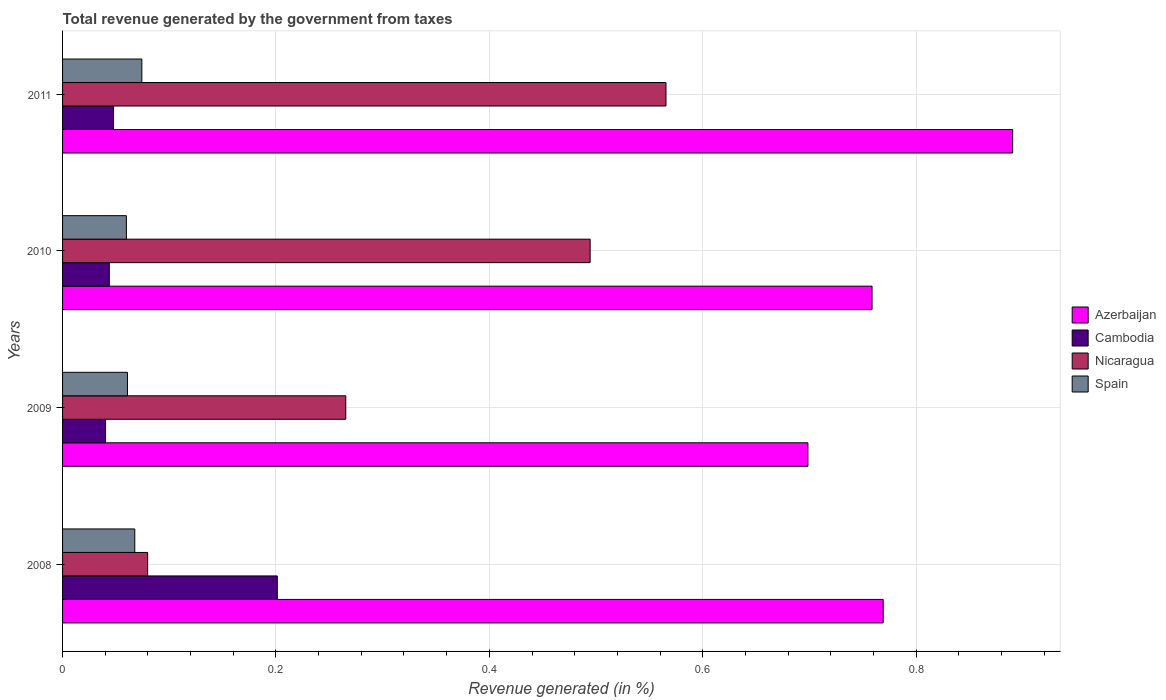Are the number of bars per tick equal to the number of legend labels?
Keep it short and to the point. Yes. Are the number of bars on each tick of the Y-axis equal?
Your answer should be compact. Yes. How many bars are there on the 4th tick from the top?
Ensure brevity in your answer.  4. How many bars are there on the 3rd tick from the bottom?
Offer a very short reply. 4. In how many cases, is the number of bars for a given year not equal to the number of legend labels?
Your answer should be very brief. 0. What is the total revenue generated in Nicaragua in 2009?
Your answer should be compact. 0.27. Across all years, what is the maximum total revenue generated in Spain?
Make the answer very short. 0.07. Across all years, what is the minimum total revenue generated in Cambodia?
Give a very brief answer. 0.04. In which year was the total revenue generated in Nicaragua minimum?
Offer a very short reply. 2008. What is the total total revenue generated in Spain in the graph?
Give a very brief answer. 0.26. What is the difference between the total revenue generated in Spain in 2009 and that in 2011?
Provide a short and direct response. -0.01. What is the difference between the total revenue generated in Cambodia in 2009 and the total revenue generated in Nicaragua in 2011?
Provide a short and direct response. -0.53. What is the average total revenue generated in Nicaragua per year?
Your answer should be very brief. 0.35. In the year 2010, what is the difference between the total revenue generated in Nicaragua and total revenue generated in Cambodia?
Your answer should be compact. 0.45. In how many years, is the total revenue generated in Azerbaijan greater than 0.44 %?
Your answer should be compact. 4. What is the ratio of the total revenue generated in Spain in 2009 to that in 2010?
Make the answer very short. 1.02. Is the total revenue generated in Nicaragua in 2008 less than that in 2010?
Your response must be concise. Yes. Is the difference between the total revenue generated in Nicaragua in 2008 and 2010 greater than the difference between the total revenue generated in Cambodia in 2008 and 2010?
Your response must be concise. No. What is the difference between the highest and the second highest total revenue generated in Spain?
Offer a very short reply. 0.01. What is the difference between the highest and the lowest total revenue generated in Spain?
Offer a terse response. 0.01. In how many years, is the total revenue generated in Azerbaijan greater than the average total revenue generated in Azerbaijan taken over all years?
Offer a terse response. 1. What does the 1st bar from the bottom in 2011 represents?
Offer a very short reply. Azerbaijan. Is it the case that in every year, the sum of the total revenue generated in Azerbaijan and total revenue generated in Spain is greater than the total revenue generated in Cambodia?
Your answer should be compact. Yes. Are all the bars in the graph horizontal?
Keep it short and to the point. Yes. How many years are there in the graph?
Your answer should be very brief. 4. Does the graph contain grids?
Provide a succinct answer. Yes. Where does the legend appear in the graph?
Ensure brevity in your answer.  Center right. How many legend labels are there?
Provide a succinct answer. 4. How are the legend labels stacked?
Give a very brief answer. Vertical. What is the title of the graph?
Offer a terse response. Total revenue generated by the government from taxes. Does "Tonga" appear as one of the legend labels in the graph?
Make the answer very short. No. What is the label or title of the X-axis?
Your response must be concise. Revenue generated (in %). What is the Revenue generated (in %) of Azerbaijan in 2008?
Make the answer very short. 0.77. What is the Revenue generated (in %) of Cambodia in 2008?
Offer a very short reply. 0.2. What is the Revenue generated (in %) of Nicaragua in 2008?
Make the answer very short. 0.08. What is the Revenue generated (in %) in Spain in 2008?
Ensure brevity in your answer.  0.07. What is the Revenue generated (in %) of Azerbaijan in 2009?
Offer a terse response. 0.7. What is the Revenue generated (in %) of Cambodia in 2009?
Give a very brief answer. 0.04. What is the Revenue generated (in %) of Nicaragua in 2009?
Offer a very short reply. 0.27. What is the Revenue generated (in %) in Spain in 2009?
Ensure brevity in your answer.  0.06. What is the Revenue generated (in %) in Azerbaijan in 2010?
Provide a short and direct response. 0.76. What is the Revenue generated (in %) in Cambodia in 2010?
Offer a very short reply. 0.04. What is the Revenue generated (in %) in Nicaragua in 2010?
Give a very brief answer. 0.49. What is the Revenue generated (in %) in Spain in 2010?
Give a very brief answer. 0.06. What is the Revenue generated (in %) in Azerbaijan in 2011?
Provide a short and direct response. 0.89. What is the Revenue generated (in %) of Cambodia in 2011?
Your answer should be very brief. 0.05. What is the Revenue generated (in %) in Nicaragua in 2011?
Offer a very short reply. 0.57. What is the Revenue generated (in %) in Spain in 2011?
Your answer should be very brief. 0.07. Across all years, what is the maximum Revenue generated (in %) of Azerbaijan?
Provide a short and direct response. 0.89. Across all years, what is the maximum Revenue generated (in %) of Cambodia?
Make the answer very short. 0.2. Across all years, what is the maximum Revenue generated (in %) of Nicaragua?
Your answer should be compact. 0.57. Across all years, what is the maximum Revenue generated (in %) of Spain?
Keep it short and to the point. 0.07. Across all years, what is the minimum Revenue generated (in %) in Azerbaijan?
Provide a short and direct response. 0.7. Across all years, what is the minimum Revenue generated (in %) of Cambodia?
Offer a very short reply. 0.04. Across all years, what is the minimum Revenue generated (in %) of Nicaragua?
Make the answer very short. 0.08. Across all years, what is the minimum Revenue generated (in %) of Spain?
Make the answer very short. 0.06. What is the total Revenue generated (in %) of Azerbaijan in the graph?
Your answer should be compact. 3.12. What is the total Revenue generated (in %) of Cambodia in the graph?
Give a very brief answer. 0.33. What is the total Revenue generated (in %) of Nicaragua in the graph?
Ensure brevity in your answer.  1.41. What is the total Revenue generated (in %) in Spain in the graph?
Provide a short and direct response. 0.26. What is the difference between the Revenue generated (in %) in Azerbaijan in 2008 and that in 2009?
Ensure brevity in your answer.  0.07. What is the difference between the Revenue generated (in %) in Cambodia in 2008 and that in 2009?
Offer a very short reply. 0.16. What is the difference between the Revenue generated (in %) of Nicaragua in 2008 and that in 2009?
Provide a short and direct response. -0.19. What is the difference between the Revenue generated (in %) of Spain in 2008 and that in 2009?
Keep it short and to the point. 0.01. What is the difference between the Revenue generated (in %) of Azerbaijan in 2008 and that in 2010?
Provide a succinct answer. 0.01. What is the difference between the Revenue generated (in %) in Cambodia in 2008 and that in 2010?
Your answer should be compact. 0.16. What is the difference between the Revenue generated (in %) in Nicaragua in 2008 and that in 2010?
Make the answer very short. -0.41. What is the difference between the Revenue generated (in %) in Spain in 2008 and that in 2010?
Keep it short and to the point. 0.01. What is the difference between the Revenue generated (in %) in Azerbaijan in 2008 and that in 2011?
Your answer should be compact. -0.12. What is the difference between the Revenue generated (in %) in Cambodia in 2008 and that in 2011?
Your response must be concise. 0.15. What is the difference between the Revenue generated (in %) of Nicaragua in 2008 and that in 2011?
Provide a succinct answer. -0.49. What is the difference between the Revenue generated (in %) of Spain in 2008 and that in 2011?
Ensure brevity in your answer.  -0.01. What is the difference between the Revenue generated (in %) in Azerbaijan in 2009 and that in 2010?
Offer a very short reply. -0.06. What is the difference between the Revenue generated (in %) of Cambodia in 2009 and that in 2010?
Ensure brevity in your answer.  -0. What is the difference between the Revenue generated (in %) in Nicaragua in 2009 and that in 2010?
Your answer should be compact. -0.23. What is the difference between the Revenue generated (in %) in Azerbaijan in 2009 and that in 2011?
Ensure brevity in your answer.  -0.19. What is the difference between the Revenue generated (in %) of Cambodia in 2009 and that in 2011?
Your response must be concise. -0.01. What is the difference between the Revenue generated (in %) in Nicaragua in 2009 and that in 2011?
Keep it short and to the point. -0.3. What is the difference between the Revenue generated (in %) in Spain in 2009 and that in 2011?
Keep it short and to the point. -0.01. What is the difference between the Revenue generated (in %) in Azerbaijan in 2010 and that in 2011?
Make the answer very short. -0.13. What is the difference between the Revenue generated (in %) in Cambodia in 2010 and that in 2011?
Offer a terse response. -0. What is the difference between the Revenue generated (in %) of Nicaragua in 2010 and that in 2011?
Your answer should be very brief. -0.07. What is the difference between the Revenue generated (in %) in Spain in 2010 and that in 2011?
Your answer should be very brief. -0.01. What is the difference between the Revenue generated (in %) in Azerbaijan in 2008 and the Revenue generated (in %) in Cambodia in 2009?
Your answer should be compact. 0.73. What is the difference between the Revenue generated (in %) in Azerbaijan in 2008 and the Revenue generated (in %) in Nicaragua in 2009?
Make the answer very short. 0.5. What is the difference between the Revenue generated (in %) of Azerbaijan in 2008 and the Revenue generated (in %) of Spain in 2009?
Give a very brief answer. 0.71. What is the difference between the Revenue generated (in %) of Cambodia in 2008 and the Revenue generated (in %) of Nicaragua in 2009?
Offer a very short reply. -0.06. What is the difference between the Revenue generated (in %) in Cambodia in 2008 and the Revenue generated (in %) in Spain in 2009?
Offer a very short reply. 0.14. What is the difference between the Revenue generated (in %) in Nicaragua in 2008 and the Revenue generated (in %) in Spain in 2009?
Ensure brevity in your answer.  0.02. What is the difference between the Revenue generated (in %) in Azerbaijan in 2008 and the Revenue generated (in %) in Cambodia in 2010?
Your answer should be compact. 0.73. What is the difference between the Revenue generated (in %) in Azerbaijan in 2008 and the Revenue generated (in %) in Nicaragua in 2010?
Offer a very short reply. 0.27. What is the difference between the Revenue generated (in %) of Azerbaijan in 2008 and the Revenue generated (in %) of Spain in 2010?
Offer a very short reply. 0.71. What is the difference between the Revenue generated (in %) in Cambodia in 2008 and the Revenue generated (in %) in Nicaragua in 2010?
Give a very brief answer. -0.29. What is the difference between the Revenue generated (in %) in Cambodia in 2008 and the Revenue generated (in %) in Spain in 2010?
Make the answer very short. 0.14. What is the difference between the Revenue generated (in %) of Nicaragua in 2008 and the Revenue generated (in %) of Spain in 2010?
Provide a succinct answer. 0.02. What is the difference between the Revenue generated (in %) in Azerbaijan in 2008 and the Revenue generated (in %) in Cambodia in 2011?
Your answer should be very brief. 0.72. What is the difference between the Revenue generated (in %) in Azerbaijan in 2008 and the Revenue generated (in %) in Nicaragua in 2011?
Ensure brevity in your answer.  0.2. What is the difference between the Revenue generated (in %) in Azerbaijan in 2008 and the Revenue generated (in %) in Spain in 2011?
Your answer should be compact. 0.69. What is the difference between the Revenue generated (in %) of Cambodia in 2008 and the Revenue generated (in %) of Nicaragua in 2011?
Provide a succinct answer. -0.36. What is the difference between the Revenue generated (in %) in Cambodia in 2008 and the Revenue generated (in %) in Spain in 2011?
Offer a terse response. 0.13. What is the difference between the Revenue generated (in %) in Nicaragua in 2008 and the Revenue generated (in %) in Spain in 2011?
Offer a terse response. 0.01. What is the difference between the Revenue generated (in %) of Azerbaijan in 2009 and the Revenue generated (in %) of Cambodia in 2010?
Provide a short and direct response. 0.65. What is the difference between the Revenue generated (in %) of Azerbaijan in 2009 and the Revenue generated (in %) of Nicaragua in 2010?
Provide a short and direct response. 0.2. What is the difference between the Revenue generated (in %) in Azerbaijan in 2009 and the Revenue generated (in %) in Spain in 2010?
Your answer should be very brief. 0.64. What is the difference between the Revenue generated (in %) of Cambodia in 2009 and the Revenue generated (in %) of Nicaragua in 2010?
Your answer should be very brief. -0.45. What is the difference between the Revenue generated (in %) in Cambodia in 2009 and the Revenue generated (in %) in Spain in 2010?
Your answer should be compact. -0.02. What is the difference between the Revenue generated (in %) in Nicaragua in 2009 and the Revenue generated (in %) in Spain in 2010?
Your answer should be compact. 0.21. What is the difference between the Revenue generated (in %) of Azerbaijan in 2009 and the Revenue generated (in %) of Cambodia in 2011?
Ensure brevity in your answer.  0.65. What is the difference between the Revenue generated (in %) in Azerbaijan in 2009 and the Revenue generated (in %) in Nicaragua in 2011?
Offer a terse response. 0.13. What is the difference between the Revenue generated (in %) in Azerbaijan in 2009 and the Revenue generated (in %) in Spain in 2011?
Offer a terse response. 0.62. What is the difference between the Revenue generated (in %) in Cambodia in 2009 and the Revenue generated (in %) in Nicaragua in 2011?
Make the answer very short. -0.53. What is the difference between the Revenue generated (in %) of Cambodia in 2009 and the Revenue generated (in %) of Spain in 2011?
Your response must be concise. -0.03. What is the difference between the Revenue generated (in %) in Nicaragua in 2009 and the Revenue generated (in %) in Spain in 2011?
Keep it short and to the point. 0.19. What is the difference between the Revenue generated (in %) of Azerbaijan in 2010 and the Revenue generated (in %) of Cambodia in 2011?
Provide a succinct answer. 0.71. What is the difference between the Revenue generated (in %) in Azerbaijan in 2010 and the Revenue generated (in %) in Nicaragua in 2011?
Ensure brevity in your answer.  0.19. What is the difference between the Revenue generated (in %) of Azerbaijan in 2010 and the Revenue generated (in %) of Spain in 2011?
Your answer should be compact. 0.68. What is the difference between the Revenue generated (in %) in Cambodia in 2010 and the Revenue generated (in %) in Nicaragua in 2011?
Offer a very short reply. -0.52. What is the difference between the Revenue generated (in %) of Cambodia in 2010 and the Revenue generated (in %) of Spain in 2011?
Make the answer very short. -0.03. What is the difference between the Revenue generated (in %) in Nicaragua in 2010 and the Revenue generated (in %) in Spain in 2011?
Offer a terse response. 0.42. What is the average Revenue generated (in %) in Azerbaijan per year?
Offer a terse response. 0.78. What is the average Revenue generated (in %) in Cambodia per year?
Make the answer very short. 0.08. What is the average Revenue generated (in %) in Nicaragua per year?
Your answer should be very brief. 0.35. What is the average Revenue generated (in %) in Spain per year?
Your response must be concise. 0.07. In the year 2008, what is the difference between the Revenue generated (in %) of Azerbaijan and Revenue generated (in %) of Cambodia?
Give a very brief answer. 0.57. In the year 2008, what is the difference between the Revenue generated (in %) of Azerbaijan and Revenue generated (in %) of Nicaragua?
Keep it short and to the point. 0.69. In the year 2008, what is the difference between the Revenue generated (in %) in Azerbaijan and Revenue generated (in %) in Spain?
Offer a very short reply. 0.7. In the year 2008, what is the difference between the Revenue generated (in %) in Cambodia and Revenue generated (in %) in Nicaragua?
Your response must be concise. 0.12. In the year 2008, what is the difference between the Revenue generated (in %) in Cambodia and Revenue generated (in %) in Spain?
Offer a terse response. 0.13. In the year 2008, what is the difference between the Revenue generated (in %) of Nicaragua and Revenue generated (in %) of Spain?
Offer a terse response. 0.01. In the year 2009, what is the difference between the Revenue generated (in %) of Azerbaijan and Revenue generated (in %) of Cambodia?
Keep it short and to the point. 0.66. In the year 2009, what is the difference between the Revenue generated (in %) in Azerbaijan and Revenue generated (in %) in Nicaragua?
Offer a very short reply. 0.43. In the year 2009, what is the difference between the Revenue generated (in %) of Azerbaijan and Revenue generated (in %) of Spain?
Your answer should be compact. 0.64. In the year 2009, what is the difference between the Revenue generated (in %) in Cambodia and Revenue generated (in %) in Nicaragua?
Offer a terse response. -0.23. In the year 2009, what is the difference between the Revenue generated (in %) of Cambodia and Revenue generated (in %) of Spain?
Provide a succinct answer. -0.02. In the year 2009, what is the difference between the Revenue generated (in %) in Nicaragua and Revenue generated (in %) in Spain?
Ensure brevity in your answer.  0.2. In the year 2010, what is the difference between the Revenue generated (in %) in Azerbaijan and Revenue generated (in %) in Cambodia?
Make the answer very short. 0.71. In the year 2010, what is the difference between the Revenue generated (in %) of Azerbaijan and Revenue generated (in %) of Nicaragua?
Ensure brevity in your answer.  0.26. In the year 2010, what is the difference between the Revenue generated (in %) in Azerbaijan and Revenue generated (in %) in Spain?
Keep it short and to the point. 0.7. In the year 2010, what is the difference between the Revenue generated (in %) in Cambodia and Revenue generated (in %) in Nicaragua?
Your answer should be compact. -0.45. In the year 2010, what is the difference between the Revenue generated (in %) in Cambodia and Revenue generated (in %) in Spain?
Make the answer very short. -0.02. In the year 2010, what is the difference between the Revenue generated (in %) of Nicaragua and Revenue generated (in %) of Spain?
Offer a terse response. 0.43. In the year 2011, what is the difference between the Revenue generated (in %) in Azerbaijan and Revenue generated (in %) in Cambodia?
Provide a succinct answer. 0.84. In the year 2011, what is the difference between the Revenue generated (in %) in Azerbaijan and Revenue generated (in %) in Nicaragua?
Your response must be concise. 0.32. In the year 2011, what is the difference between the Revenue generated (in %) of Azerbaijan and Revenue generated (in %) of Spain?
Your answer should be very brief. 0.82. In the year 2011, what is the difference between the Revenue generated (in %) of Cambodia and Revenue generated (in %) of Nicaragua?
Keep it short and to the point. -0.52. In the year 2011, what is the difference between the Revenue generated (in %) of Cambodia and Revenue generated (in %) of Spain?
Your answer should be very brief. -0.03. In the year 2011, what is the difference between the Revenue generated (in %) of Nicaragua and Revenue generated (in %) of Spain?
Offer a very short reply. 0.49. What is the ratio of the Revenue generated (in %) of Azerbaijan in 2008 to that in 2009?
Provide a short and direct response. 1.1. What is the ratio of the Revenue generated (in %) of Cambodia in 2008 to that in 2009?
Make the answer very short. 4.99. What is the ratio of the Revenue generated (in %) of Nicaragua in 2008 to that in 2009?
Your answer should be compact. 0.3. What is the ratio of the Revenue generated (in %) of Spain in 2008 to that in 2009?
Provide a succinct answer. 1.11. What is the ratio of the Revenue generated (in %) in Azerbaijan in 2008 to that in 2010?
Provide a short and direct response. 1.01. What is the ratio of the Revenue generated (in %) of Cambodia in 2008 to that in 2010?
Your response must be concise. 4.59. What is the ratio of the Revenue generated (in %) in Nicaragua in 2008 to that in 2010?
Your answer should be very brief. 0.16. What is the ratio of the Revenue generated (in %) of Spain in 2008 to that in 2010?
Provide a succinct answer. 1.13. What is the ratio of the Revenue generated (in %) of Azerbaijan in 2008 to that in 2011?
Offer a very short reply. 0.86. What is the ratio of the Revenue generated (in %) of Cambodia in 2008 to that in 2011?
Make the answer very short. 4.21. What is the ratio of the Revenue generated (in %) in Nicaragua in 2008 to that in 2011?
Make the answer very short. 0.14. What is the ratio of the Revenue generated (in %) of Spain in 2008 to that in 2011?
Keep it short and to the point. 0.91. What is the ratio of the Revenue generated (in %) in Azerbaijan in 2009 to that in 2010?
Your response must be concise. 0.92. What is the ratio of the Revenue generated (in %) in Cambodia in 2009 to that in 2010?
Ensure brevity in your answer.  0.92. What is the ratio of the Revenue generated (in %) in Nicaragua in 2009 to that in 2010?
Offer a very short reply. 0.54. What is the ratio of the Revenue generated (in %) of Spain in 2009 to that in 2010?
Your answer should be very brief. 1.02. What is the ratio of the Revenue generated (in %) of Azerbaijan in 2009 to that in 2011?
Provide a succinct answer. 0.78. What is the ratio of the Revenue generated (in %) of Cambodia in 2009 to that in 2011?
Keep it short and to the point. 0.84. What is the ratio of the Revenue generated (in %) of Nicaragua in 2009 to that in 2011?
Provide a short and direct response. 0.47. What is the ratio of the Revenue generated (in %) of Spain in 2009 to that in 2011?
Keep it short and to the point. 0.82. What is the ratio of the Revenue generated (in %) of Azerbaijan in 2010 to that in 2011?
Provide a short and direct response. 0.85. What is the ratio of the Revenue generated (in %) of Cambodia in 2010 to that in 2011?
Ensure brevity in your answer.  0.92. What is the ratio of the Revenue generated (in %) of Nicaragua in 2010 to that in 2011?
Keep it short and to the point. 0.87. What is the ratio of the Revenue generated (in %) in Spain in 2010 to that in 2011?
Keep it short and to the point. 0.81. What is the difference between the highest and the second highest Revenue generated (in %) of Azerbaijan?
Ensure brevity in your answer.  0.12. What is the difference between the highest and the second highest Revenue generated (in %) in Cambodia?
Give a very brief answer. 0.15. What is the difference between the highest and the second highest Revenue generated (in %) in Nicaragua?
Offer a very short reply. 0.07. What is the difference between the highest and the second highest Revenue generated (in %) of Spain?
Make the answer very short. 0.01. What is the difference between the highest and the lowest Revenue generated (in %) of Azerbaijan?
Your answer should be compact. 0.19. What is the difference between the highest and the lowest Revenue generated (in %) in Cambodia?
Give a very brief answer. 0.16. What is the difference between the highest and the lowest Revenue generated (in %) of Nicaragua?
Offer a terse response. 0.49. What is the difference between the highest and the lowest Revenue generated (in %) of Spain?
Give a very brief answer. 0.01. 